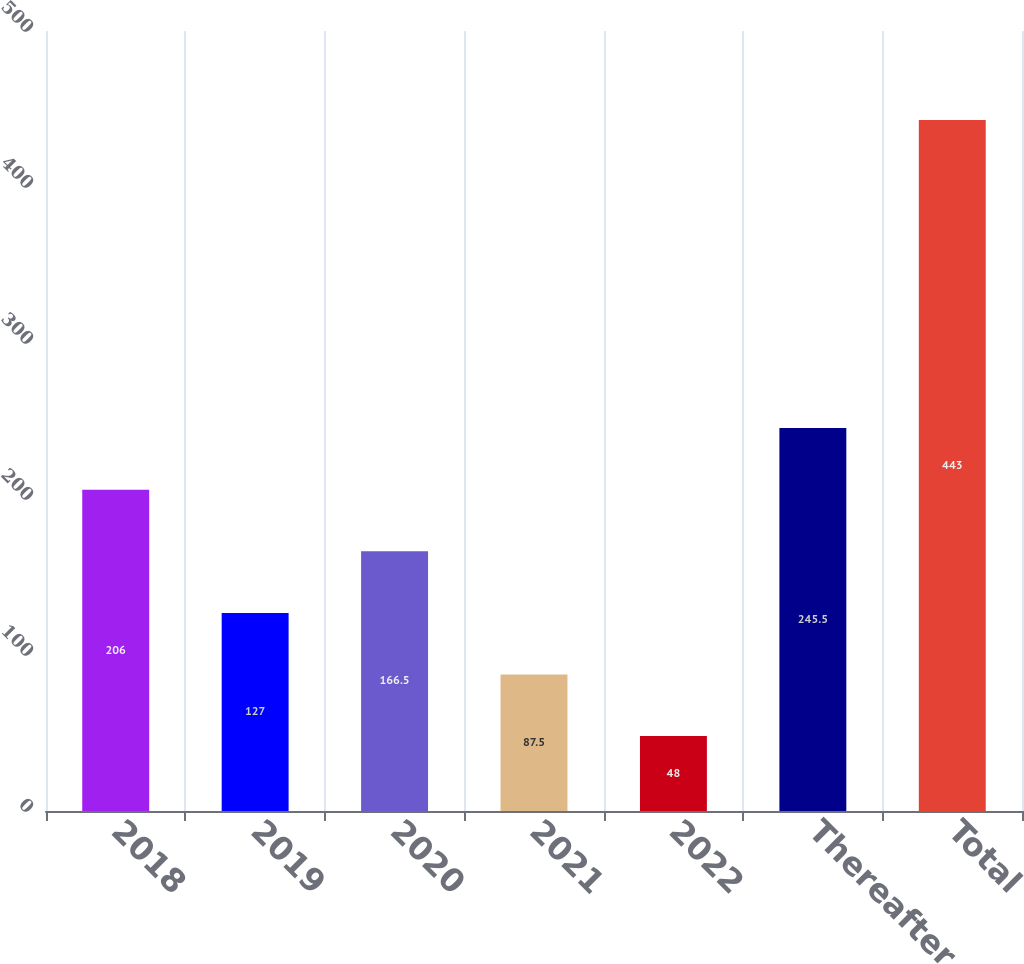<chart> <loc_0><loc_0><loc_500><loc_500><bar_chart><fcel>2018<fcel>2019<fcel>2020<fcel>2021<fcel>2022<fcel>Thereafter<fcel>Total<nl><fcel>206<fcel>127<fcel>166.5<fcel>87.5<fcel>48<fcel>245.5<fcel>443<nl></chart> 